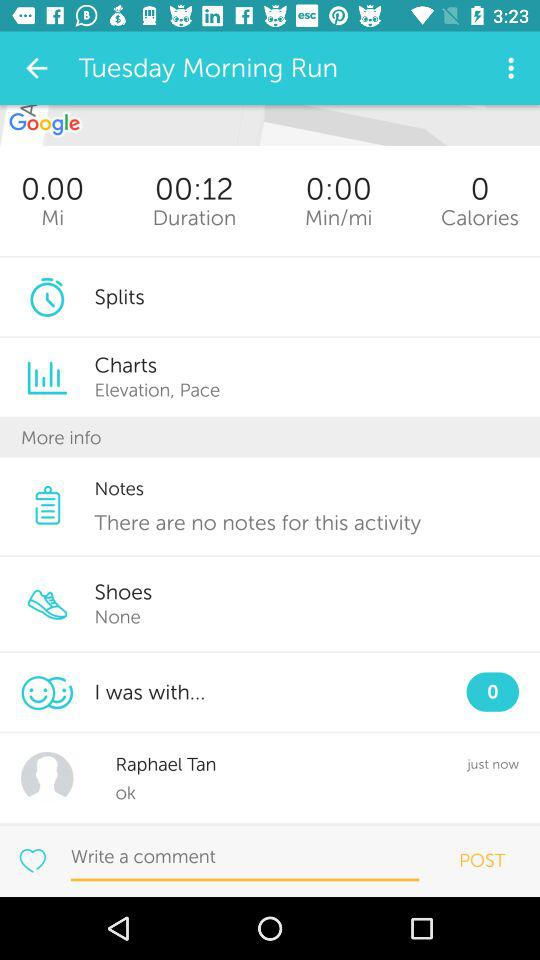How many calories did I burn?
Answer the question using a single word or phrase. 0 